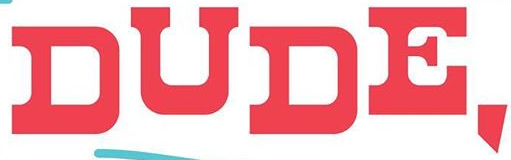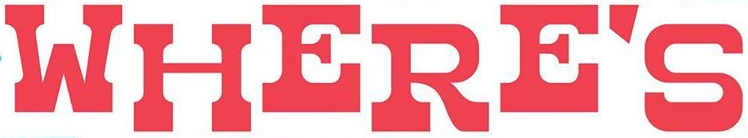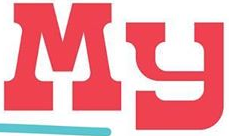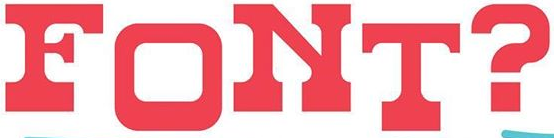Read the text from these images in sequence, separated by a semicolon. DUDE,; WHERE'S; My; FONT? 